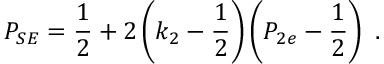<formula> <loc_0><loc_0><loc_500><loc_500>P _ { S E } = { \frac { 1 } { 2 } } + 2 \left ( k _ { 2 } - { \frac { 1 } { 2 } } \right ) \left ( P _ { 2 e } - { \frac { 1 } { 2 } } \right ) \ .</formula> 